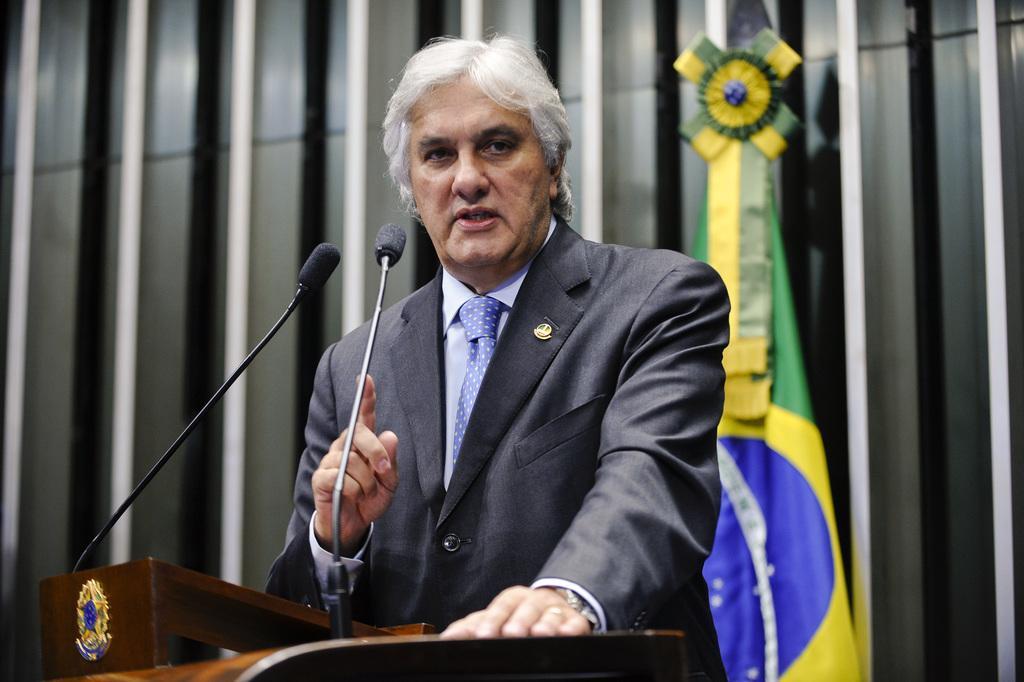Can you describe this image briefly? In the image we can see there is a man wearing a formal suit and standing near the podium. There are two mics attached to the podium and behind there is a flag. There is a small badge on the suit. 